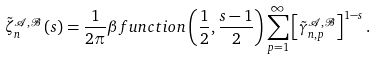<formula> <loc_0><loc_0><loc_500><loc_500>\tilde { \zeta } _ { n } ^ { { \mathcal { A } } , { \mathcal { B } } } \left ( s \right ) = \frac { 1 } { 2 \pi } \beta f u n c t i o n \left ( \frac { 1 } { 2 } , \frac { s - 1 } { 2 } \right ) \sum _ { p = 1 } ^ { \infty } \left [ \tilde { \gamma } _ { n , p } ^ { { \mathcal { A } } , { \mathcal { B } } } \right ] ^ { 1 - s } .</formula> 